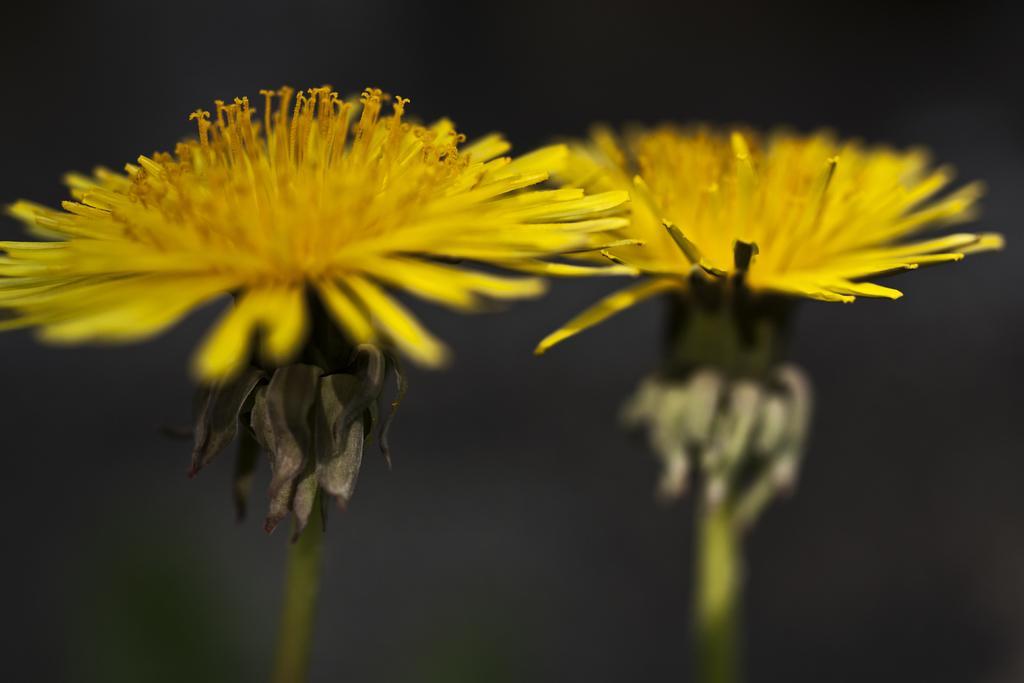How would you summarize this image in a sentence or two? In this picture there are two yellow color flowers. At the back there is a black background. 